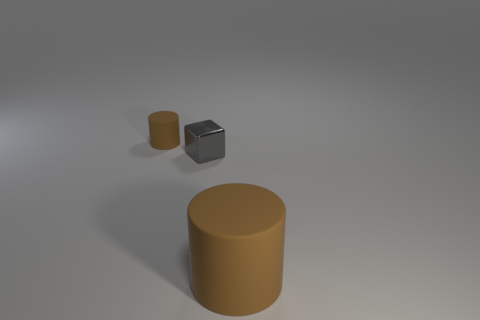Add 1 large objects. How many objects exist? 4 Subtract all cylinders. How many objects are left? 1 Subtract 2 cylinders. How many cylinders are left? 0 Subtract all gray shiny cubes. Subtract all cyan objects. How many objects are left? 2 Add 2 big cylinders. How many big cylinders are left? 3 Add 2 small cylinders. How many small cylinders exist? 3 Subtract 1 brown cylinders. How many objects are left? 2 Subtract all red cubes. Subtract all brown spheres. How many cubes are left? 1 